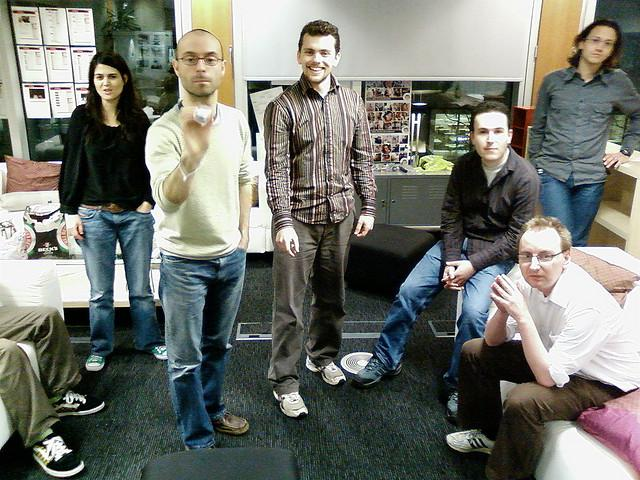Where is the group focusing their attention? Please explain your reasoning. screen. The group is watching something on the screen. 